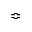<formula> <loc_0><loc_0><loc_500><loc_500>\ B u m p e q</formula> 